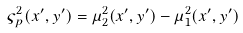Convert formula to latex. <formula><loc_0><loc_0><loc_500><loc_500>\varsigma _ { p } ^ { 2 } ( x ^ { \prime } , y ^ { \prime } ) = \mu _ { 2 } ^ { 2 } ( x ^ { \prime } , y ^ { \prime } ) - \mu _ { 1 } ^ { 2 } ( x ^ { \prime } , y ^ { \prime } )</formula> 